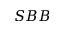Convert formula to latex. <formula><loc_0><loc_0><loc_500><loc_500>S B B</formula> 